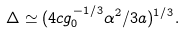<formula> <loc_0><loc_0><loc_500><loc_500>\Delta \simeq ( 4 c g _ { 0 } ^ { - 1 / 3 } \alpha ^ { 2 } / 3 a ) ^ { 1 / 3 } .</formula> 